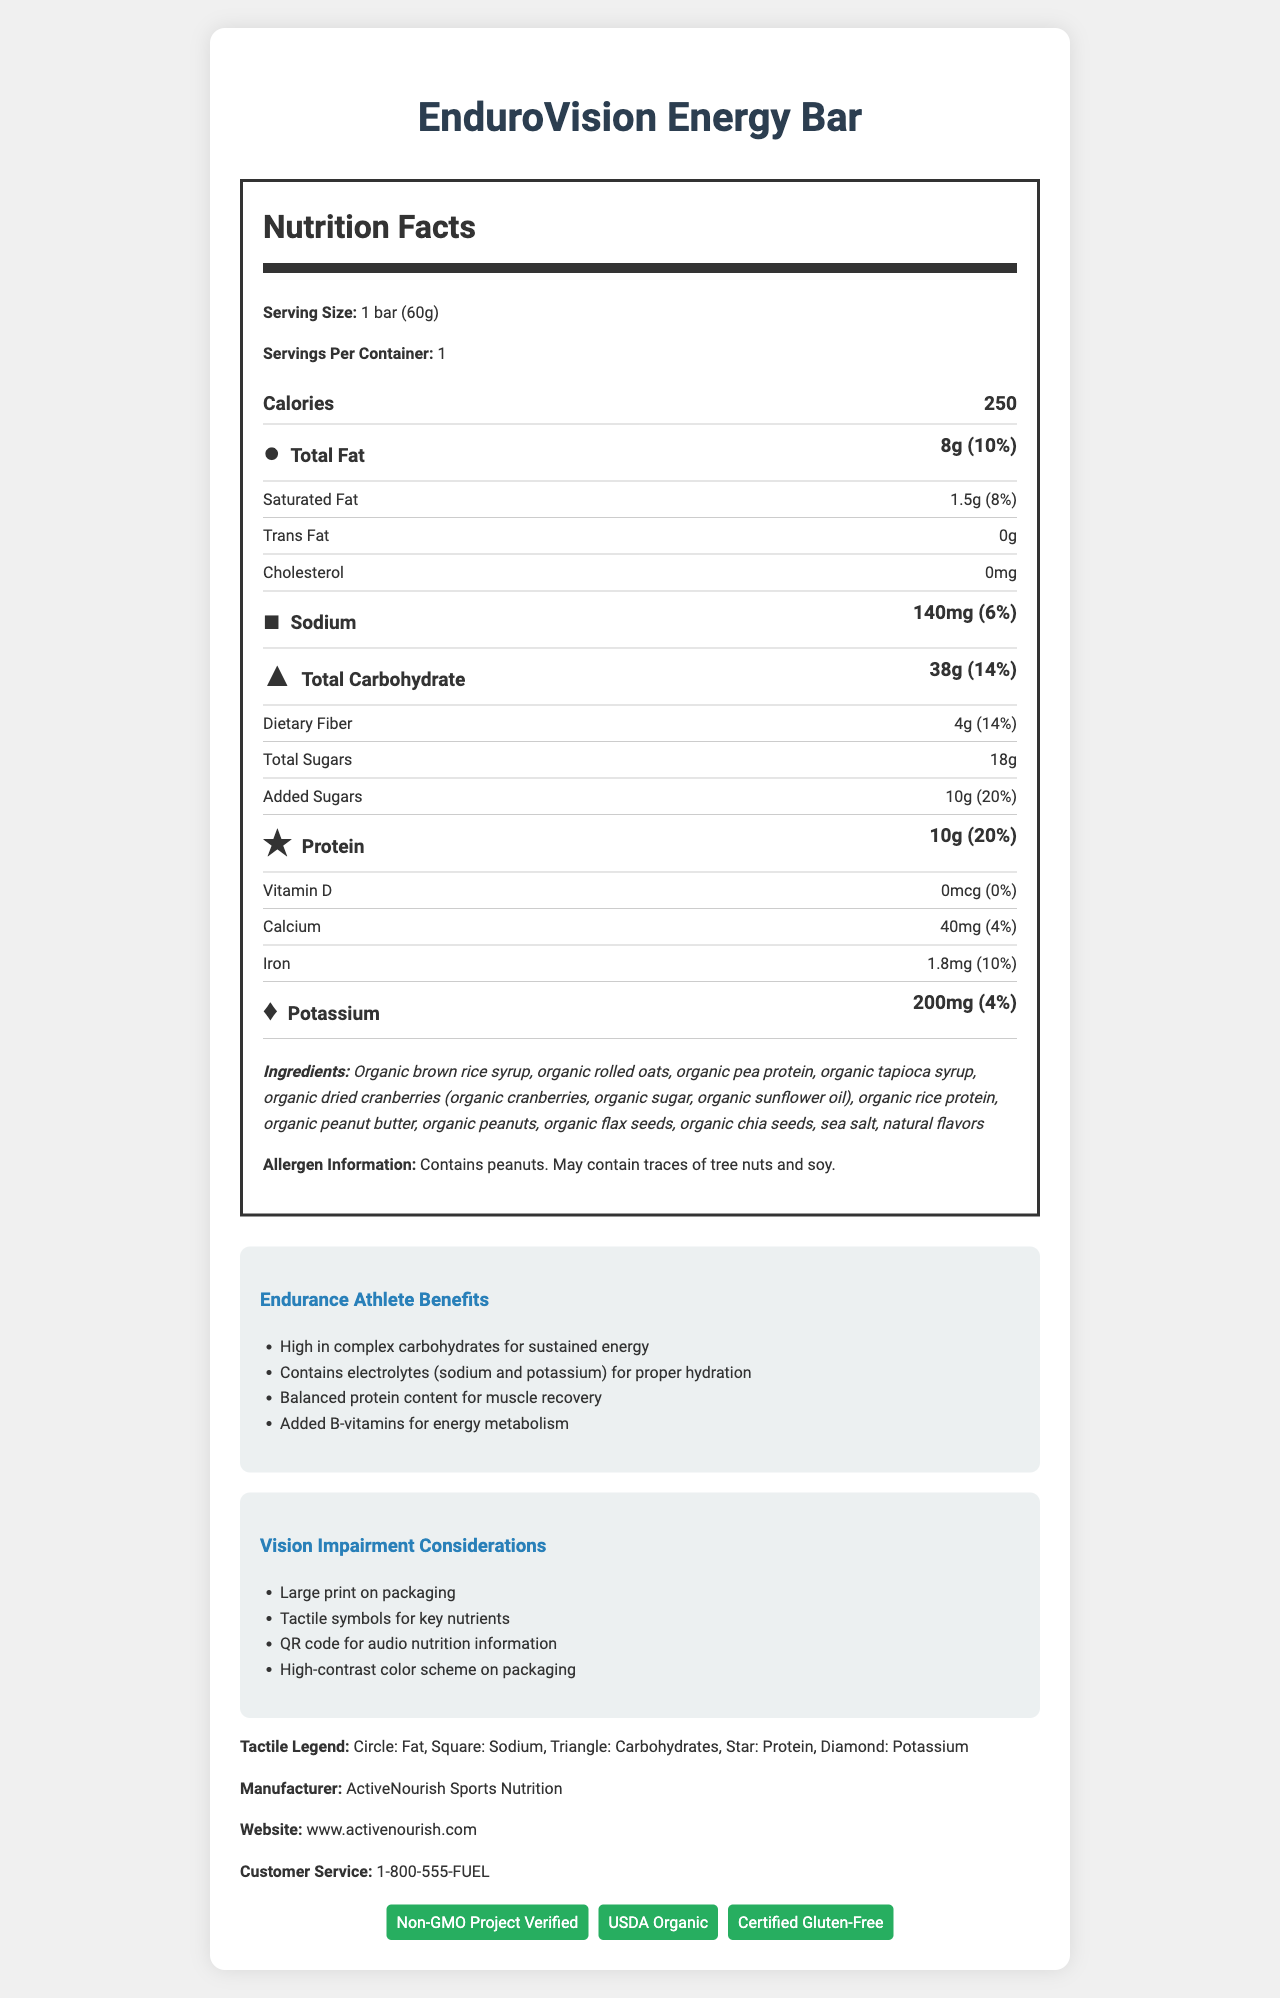what is the serving size of the EnduroVision Energy Bar? The serving size is indicated at the beginning of the Nutrition Facts label, clearly stating "Serving Size: 1 bar (60g)".
Answer: 1 bar (60g) what are the calories in one serving of the EnduroVision Energy Bar? The calorie count is usually prominently displayed in the Nutrition Facts label, marked as "Calories: 250".
Answer: 250 what shape tactile symbol represents sodium? The tactile legend at the bottom of the document indicates that a square symbolizes sodium.
Answer: square what is the percent daily value of protein in the EnduroVision Energy Bar? In the Nutrition Facts label, the protein content is given as "10g (20%)" indicating 10 grams and 20% daily value.
Answer: 20% which nutrient has the highest percent daily value, apart from calories? Scanning through the percent daily values in the Nutrition Facts, Vitamin B6 has the highest at 29%.
Answer: Vitamin B6 (29%) what certifications does the EnduroVision Energy Bar have? A. Non-GMO Project Verified B. USDA Organic C. Certified Gluten-Free D. All of the above The document states at the bottom that the product is Non-GMO Project Verified, USDA Organic, and Certified Gluten-Free.
Answer: D. All of the above which key nutrient is indicated with a circle tactile symbol? A. Total Fat B. Sodium C. Total Carbohydrate D. Protein According to the tactile legend and the label, a circle represents fat.
Answer: A. Total Fat does the EnduroVision Energy Bar contain any trans fat? The Nutrition Facts label lists "Trans Fat: 0g" meaning it contains no trans fat.
Answer: No summarize the main benefits and features of the EnduroVision Energy Bar for endurance athletes and individuals with vision impairment. The document outlines specific benefits for endurance athletes including complex carbohydrates, balanced protein, electrolytes, and added B-vitamins. Vision impairment considerations include large print, tactile symbols, a QR code, and high-contrast colors, ensuring accessibility.
Answer: The EnduroVision Energy Bar is designed for endurance athletes, offering high complex carbohydrates for sustained energy, balanced protein for muscle recovery, and electrolytes like sodium and potassium for hydration. It also includes added B-vitamins for energy metabolism. For individuals with vision impairment, it features large print, tactile symbols for key nutrients, a QR code for audio information, and a high-contrast color scheme. how much dietary fiber is in one serving of the EnduroVision Energy Bar? The Nutrition Facts label states "Dietary Fiber: 4g (14%)".
Answer: 4g what is the sodium content in the EnduroVision Energy Bar? Sodium content is listed in the Nutrition Facts as "Sodium: 140mg (6%)".
Answer: 140mg what are the main ingredients used in the EnduroVision Energy Bar? The ingredients list highlights organic brown rice syrup, rolled oats, pea protein, tapioca syrup, dried cranberries (with additional organic components), rice protein, peanut butter, and other organic ingredients.
Answer: Organic brown rice syrup, organic rolled oats, organic pea protein, organic tapioca syrup, organic dried cranberries, and several others. does the EnduroVision Energy Bar contain any allergens? If so, what are they? The allergen information provided in the document specifies that the bar contains peanuts and may also contain tree nuts and soy.
Answer: Yes, it contains peanuts and may contain traces of tree nuts and soy. what is the percent daily value for potassium? The Nutrition Facts label lists "Potassium: 200mg (4%)" indicating the percent daily value.
Answer: 4% can you determine if the EnduroVision Energy Bar is considered vegan based on the document? The document does not provide explicit information regarding whether the product is vegan. More details are needed to determine the absence of all animal-derived ingredients.
Answer: Cannot be determined 